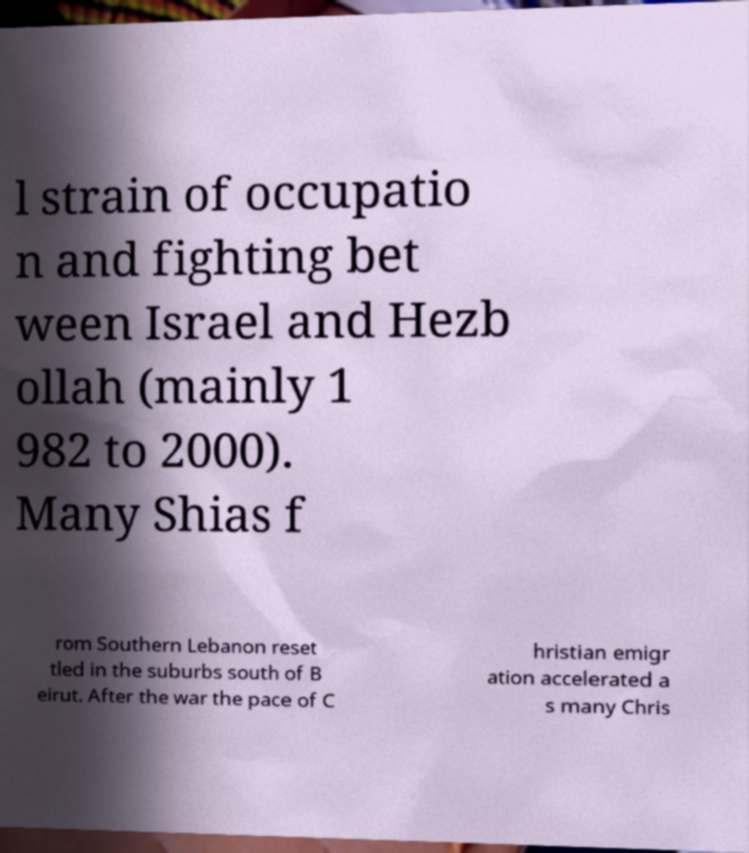I need the written content from this picture converted into text. Can you do that? l strain of occupatio n and fighting bet ween Israel and Hezb ollah (mainly 1 982 to 2000). Many Shias f rom Southern Lebanon reset tled in the suburbs south of B eirut. After the war the pace of C hristian emigr ation accelerated a s many Chris 